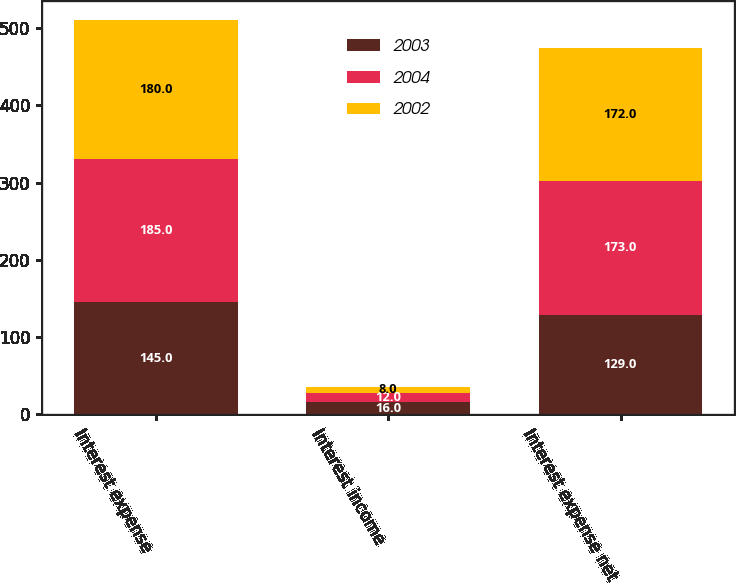<chart> <loc_0><loc_0><loc_500><loc_500><stacked_bar_chart><ecel><fcel>Interest expense<fcel>Interest income<fcel>Interest expense net<nl><fcel>2003<fcel>145<fcel>16<fcel>129<nl><fcel>2004<fcel>185<fcel>12<fcel>173<nl><fcel>2002<fcel>180<fcel>8<fcel>172<nl></chart> 